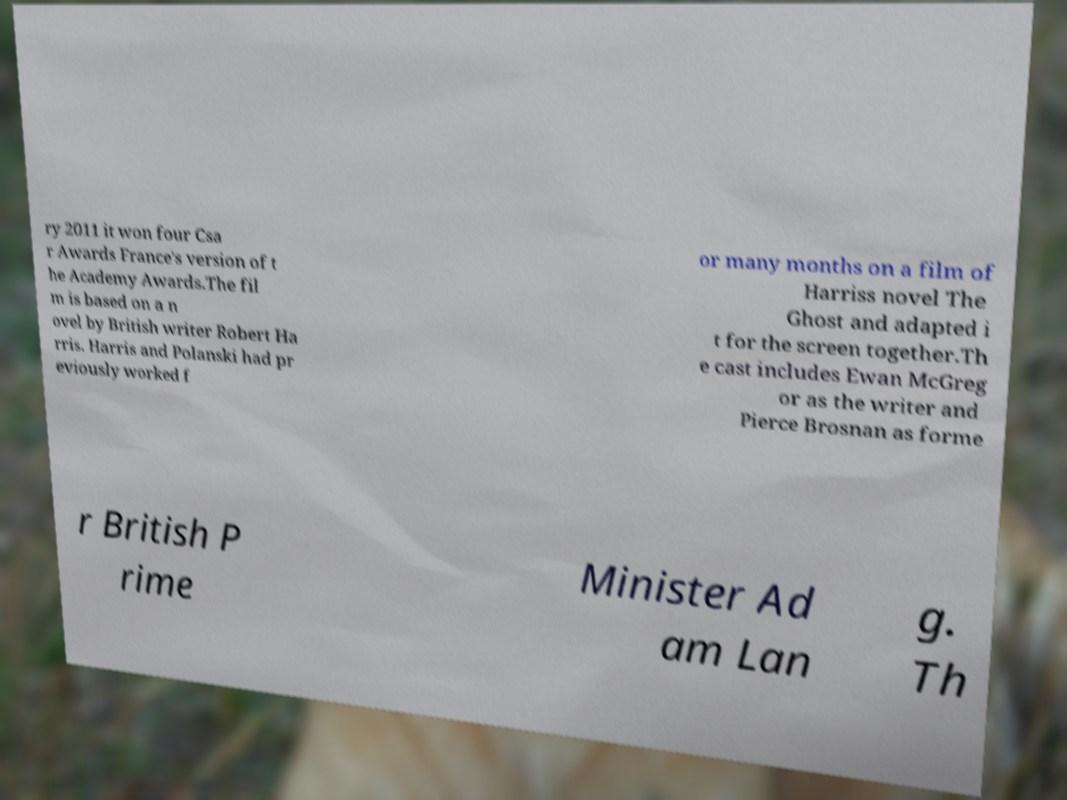I need the written content from this picture converted into text. Can you do that? ry 2011 it won four Csa r Awards France's version of t he Academy Awards.The fil m is based on a n ovel by British writer Robert Ha rris. Harris and Polanski had pr eviously worked f or many months on a film of Harriss novel The Ghost and adapted i t for the screen together.Th e cast includes Ewan McGreg or as the writer and Pierce Brosnan as forme r British P rime Minister Ad am Lan g. Th 